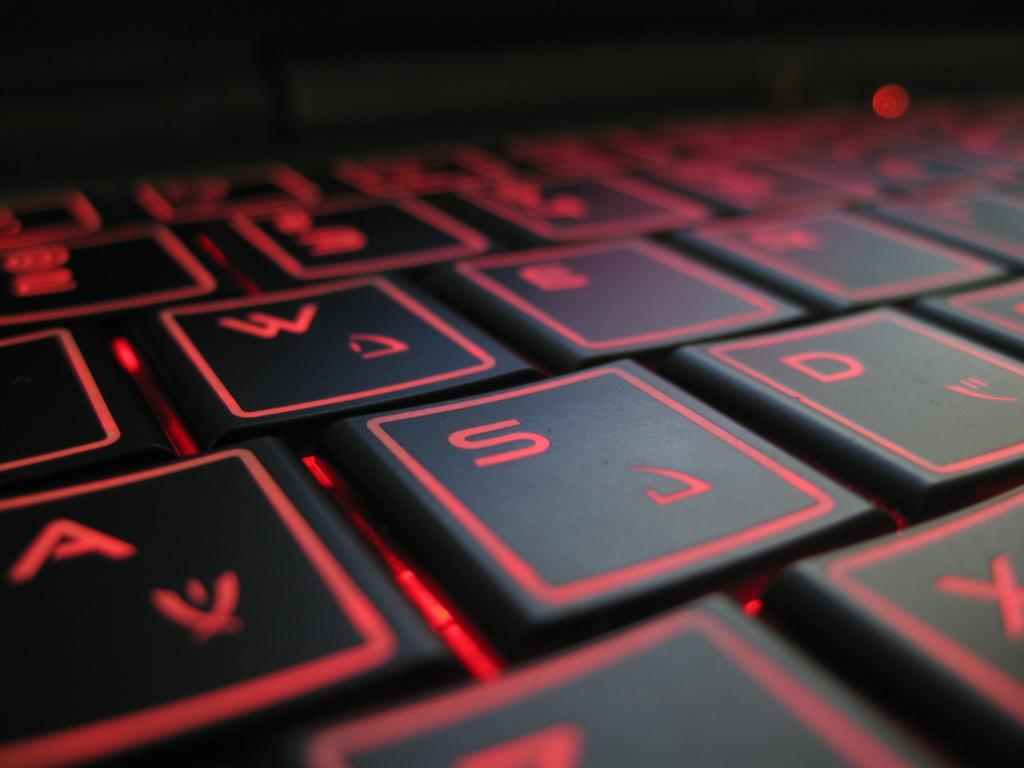<image>
Create a compact narrative representing the image presented. QWERTY standard keys are shown on this keyboard with the S key highlighted. 